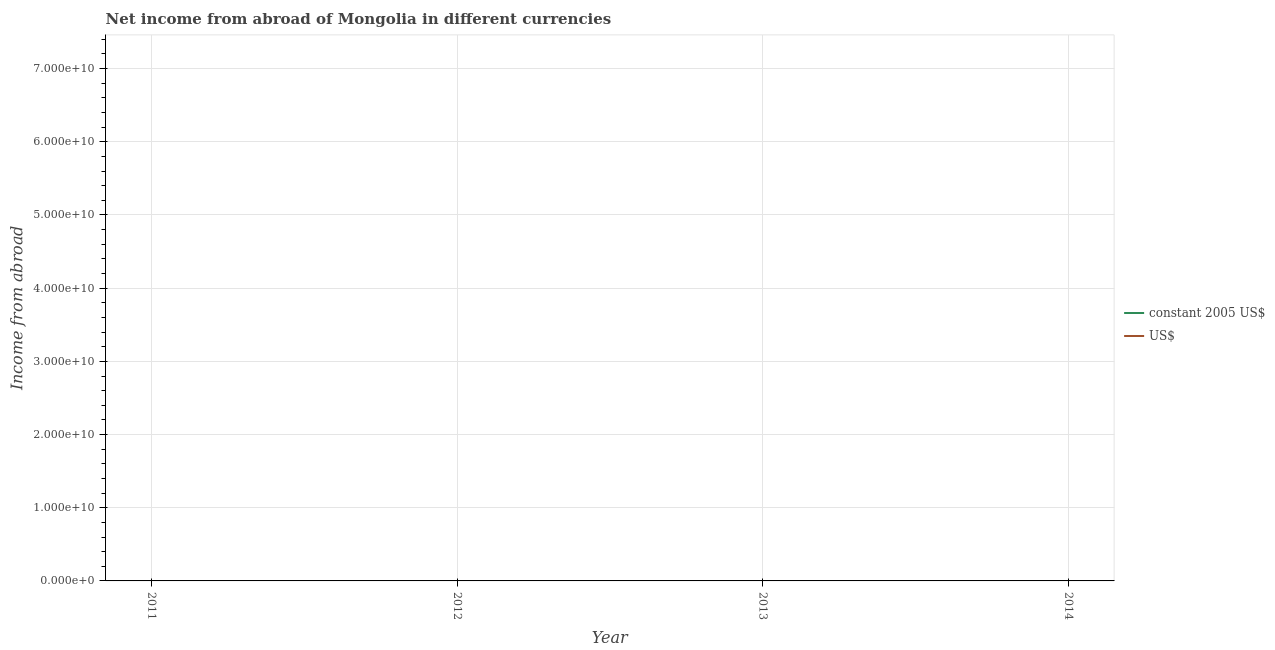How many different coloured lines are there?
Make the answer very short. 0. Is the number of lines equal to the number of legend labels?
Make the answer very short. No. Across all years, what is the minimum income from abroad in us$?
Offer a terse response. 0. What is the total income from abroad in constant 2005 us$ in the graph?
Make the answer very short. 0. In how many years, is the income from abroad in us$ greater than 28000000000 units?
Your answer should be very brief. 0. In how many years, is the income from abroad in us$ greater than the average income from abroad in us$ taken over all years?
Ensure brevity in your answer.  0. How many years are there in the graph?
Keep it short and to the point. 4. What is the difference between two consecutive major ticks on the Y-axis?
Provide a succinct answer. 1.00e+1. Are the values on the major ticks of Y-axis written in scientific E-notation?
Offer a terse response. Yes. Does the graph contain grids?
Make the answer very short. Yes. How are the legend labels stacked?
Provide a short and direct response. Vertical. What is the title of the graph?
Provide a succinct answer. Net income from abroad of Mongolia in different currencies. What is the label or title of the X-axis?
Offer a terse response. Year. What is the label or title of the Y-axis?
Your response must be concise. Income from abroad. What is the Income from abroad of constant 2005 US$ in 2011?
Your response must be concise. 0. What is the Income from abroad of US$ in 2011?
Give a very brief answer. 0. What is the Income from abroad in constant 2005 US$ in 2012?
Your answer should be very brief. 0. What is the Income from abroad of US$ in 2012?
Keep it short and to the point. 0. What is the Income from abroad in constant 2005 US$ in 2013?
Your response must be concise. 0. What is the Income from abroad of US$ in 2013?
Provide a short and direct response. 0. What is the Income from abroad of constant 2005 US$ in 2014?
Offer a very short reply. 0. What is the average Income from abroad of constant 2005 US$ per year?
Offer a terse response. 0. What is the average Income from abroad in US$ per year?
Offer a very short reply. 0. 